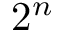<formula> <loc_0><loc_0><loc_500><loc_500>2 ^ { n }</formula> 